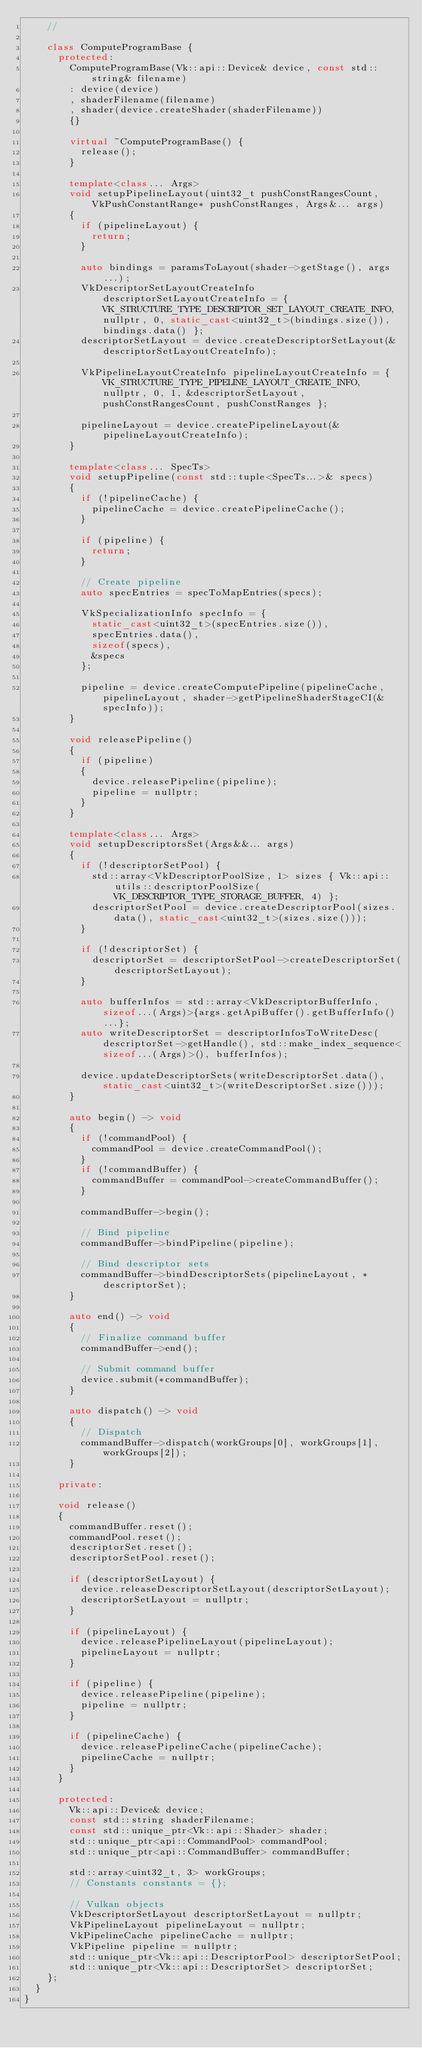Convert code to text. <code><loc_0><loc_0><loc_500><loc_500><_C++_>    //

    class ComputeProgramBase {
      protected:
        ComputeProgramBase(Vk::api::Device& device, const std::string& filename)
        : device(device)
        , shaderFilename(filename)
        , shader(device.createShader(shaderFilename))
        {}

        virtual ~ComputeProgramBase() {
          release();
        }

        template<class... Args>
        void setupPipelineLayout(uint32_t pushConstRangesCount, VkPushConstantRange* pushConstRanges, Args&... args)
        {
          if (pipelineLayout) {
            return;
          }

          auto bindings = paramsToLayout(shader->getStage(), args...);
          VkDescriptorSetLayoutCreateInfo descriptorSetLayoutCreateInfo = { VK_STRUCTURE_TYPE_DESCRIPTOR_SET_LAYOUT_CREATE_INFO, nullptr, 0, static_cast<uint32_t>(bindings.size()), bindings.data() };         
          descriptorSetLayout = device.createDescriptorSetLayout(&descriptorSetLayoutCreateInfo);

          VkPipelineLayoutCreateInfo pipelineLayoutCreateInfo = { VK_STRUCTURE_TYPE_PIPELINE_LAYOUT_CREATE_INFO, nullptr, 0, 1, &descriptorSetLayout, pushConstRangesCount, pushConstRanges };

          pipelineLayout = device.createPipelineLayout(&pipelineLayoutCreateInfo);
        }

        template<class... SpecTs>
        void setupPipeline(const std::tuple<SpecTs...>& specs)
        {
          if (!pipelineCache) {
            pipelineCache = device.createPipelineCache();
          }

          if (pipeline) {
            return;
          }

          // Create pipeline
          auto specEntries = specToMapEntries(specs);

          VkSpecializationInfo specInfo = {
            static_cast<uint32_t>(specEntries.size()),
            specEntries.data(),
            sizeof(specs),
            &specs
          };

          pipeline = device.createComputePipeline(pipelineCache, pipelineLayout, shader->getPipelineShaderStageCI(&specInfo));
        }

        void releasePipeline()
        {
          if (pipeline)
          {
            device.releasePipeline(pipeline);
            pipeline = nullptr;
          }
        }

        template<class... Args>
        void setupDescriptorsSet(Args&&... args)
        {
          if (!descriptorSetPool) {
            std::array<VkDescriptorPoolSize, 1> sizes { Vk::api::utils::descriptorPoolSize(VK_DESCRIPTOR_TYPE_STORAGE_BUFFER, 4) };
            descriptorSetPool = device.createDescriptorPool(sizes.data(), static_cast<uint32_t>(sizes.size()));
          }

          if (!descriptorSet) {
            descriptorSet = descriptorSetPool->createDescriptorSet(descriptorSetLayout);
          }

          auto bufferInfos = std::array<VkDescriptorBufferInfo, sizeof...(Args)>{args.getApiBuffer().getBufferInfo()...};
          auto writeDescriptorSet = descriptorInfosToWriteDesc(descriptorSet->getHandle(), std::make_index_sequence<sizeof...(Args)>(), bufferInfos);

          device.updateDescriptorSets(writeDescriptorSet.data(), static_cast<uint32_t>(writeDescriptorSet.size()));
        }

        auto begin() -> void
        {
          if (!commandPool) {
            commandPool = device.createCommandPool();
          }
          if (!commandBuffer) {
            commandBuffer = commandPool->createCommandBuffer();
          }

          commandBuffer->begin();

          // Bind pipeline
          commandBuffer->bindPipeline(pipeline);

          // Bind descriptor sets
          commandBuffer->bindDescriptorSets(pipelineLayout, *descriptorSet);
        }

        auto end() -> void
        {
          // Finalize command buffer
          commandBuffer->end();

          // Submit command buffer
          device.submit(*commandBuffer);
        }

        auto dispatch() -> void
        {
          // Dispatch
          commandBuffer->dispatch(workGroups[0], workGroups[1], workGroups[2]);
        }

      private:

      void release()
      { 
        commandBuffer.reset();
        commandPool.reset();
        descriptorSet.reset();
        descriptorSetPool.reset();

        if (descriptorSetLayout) {
          device.releaseDescriptorSetLayout(descriptorSetLayout);
          descriptorSetLayout = nullptr;
        }

        if (pipelineLayout) {
          device.releasePipelineLayout(pipelineLayout);
          pipelineLayout = nullptr;
        }

        if (pipeline) {
          device.releasePipeline(pipeline);
          pipeline = nullptr;
        }

        if (pipelineCache) {
          device.releasePipelineCache(pipelineCache);
          pipelineCache = nullptr;
        }
      }

      protected:
        Vk::api::Device& device;
        const std::string shaderFilename;
        const std::unique_ptr<Vk::api::Shader> shader;
        std::unique_ptr<api::CommandPool> commandPool;
        std::unique_ptr<api::CommandBuffer> commandBuffer;
        
        std::array<uint32_t, 3> workGroups;
        // Constants constants = {};

        // Vulkan objects
        VkDescriptorSetLayout descriptorSetLayout = nullptr;
        VkPipelineLayout pipelineLayout = nullptr;
        VkPipelineCache pipelineCache = nullptr;
        VkPipeline pipeline = nullptr;
        std::unique_ptr<Vk::api::DescriptorPool> descriptorSetPool;
        std::unique_ptr<Vk::api::DescriptorSet> descriptorSet;
    };
  }
}</code> 